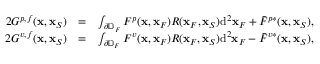Convert formula to latex. <formula><loc_0><loc_0><loc_500><loc_500>\begin{array} { r l r } { 2 G ^ { p , f } ( { x } , { x } _ { S } ) } & { = } & { \int _ { \partial \mathbb { D } _ { F } } F ^ { p } ( { x } , { x } _ { F } ) R ( { x } _ { F } , { x } _ { S } ) d ^ { 2 } { x } _ { F } + \bar { F } ^ { p * } ( { x } , { x } _ { S } ) , } \\ { 2 G ^ { v , f } ( { x } , { x } _ { S } ) } & { = } & { \int _ { \partial \mathbb { D } _ { F } } F ^ { v } ( { x } , { x } _ { F } ) R ( { x } _ { F } , { x } _ { S } ) d ^ { 2 } { x } _ { F } - \bar { F } ^ { v * } ( { x } , { x } _ { S } ) , } \end{array}</formula> 